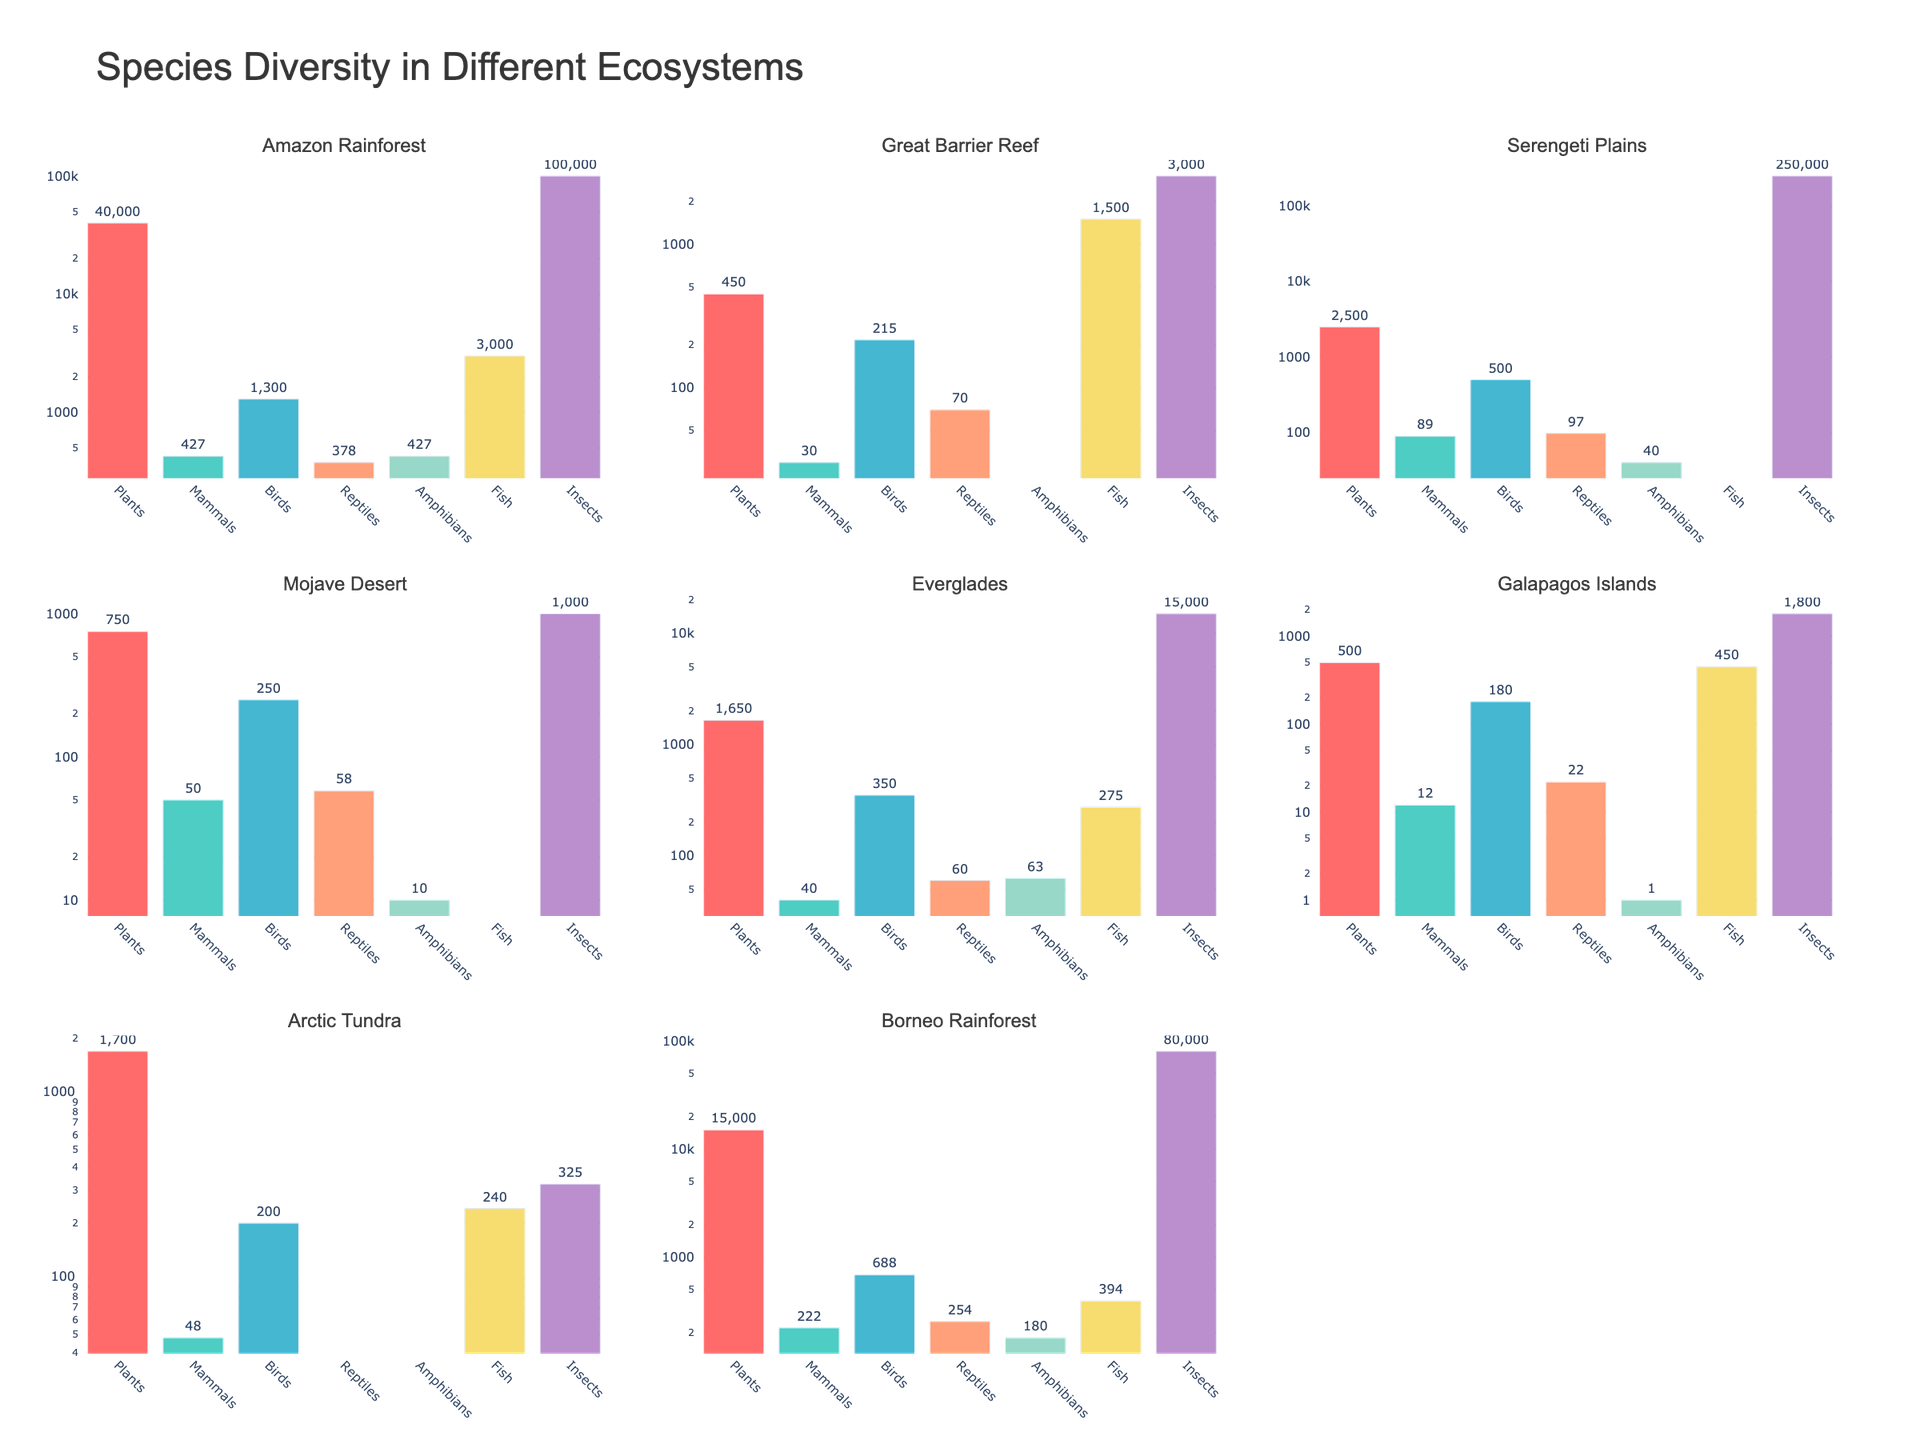How many candidates are included in the bar chart of Direct Mail fundraising? The bar chart displays bars representing each candidate in the dataset. By counting the bars, we see that there are 8 candidates in the figure.
Answer: 8 What's the highest percentage of fundraising through Social Media, as shown in the pie chart? In the pie chart, the percentages are labeled along with the candidates. The highest percentage percentage for Social Media is 28%.
Answer: 28% Which candidate has the highest percentage of fundraising through events, according to the heatmap? By examining the heatmap, looking at the column for Events, we see Chris Christie has the highest value at 30%.
Answer: Chris Christie Which fundraising method shows the lowest percentage for Donald Trump? By observing the individual bars labeled with their respective methods for Donald Trump, the Phone Banking method has the lowest percentage at 5%.
Answer: Phone Banking What is the relationship between Email and Events fundraising percentages for Nikki Haley in the scatter plot? By locating Nikki Haley's point in the scatter plot and cross-referencing Email and Events values on their respective axes, we find her Email percentage at 30% and Events percentage at 17%.
Answer: Email: 30%, Events: 17% Which fundraising method has the highest median value across all candidates as seen in the heatmap? By identifying individual method columns and determining the middle value when sorted, the Direct Mail fundraising method has the highest median value at 25.5%.
Answer: Direct Mail Who has a higher fundraising percentage through Direct Mail: Ted Cruz or Marco Rubio? By checking the Direct Mail bars for Ted Cruz and Marco Rubio in the bar chart, we find Ted Cruz has 28%, and Marco Rubio has 22%. Thus, Ted Cruz has a higher percentage.
Answer: Ted Cruz Are there any candidates with equal percentages across all five fundraising methods? By scrutinizing the heatmap and comparing the values for all methods for each candidate, no candidate has equal percentages across all methods.
Answer: No What is the average percentage of phone banking across all candidates? By summing the percentages for Phone Banking across all candidates: (5 + 10 + 10 + 10 + 10 + 10 + 10 + 10) = 75, and dividing by the number of candidates, 8, we get an average of 9.375%.
Answer: 9.375% Which candidate stands out on the scatter plot with the highest value on the Events axis while also being marked prominently in size/color? Chris Christie stands at the highest point on the Events axis in the scatter plot with an Events percentage of 30%, marked with a distinctive size/color suggesting significance.
Answer: Chris Christie 